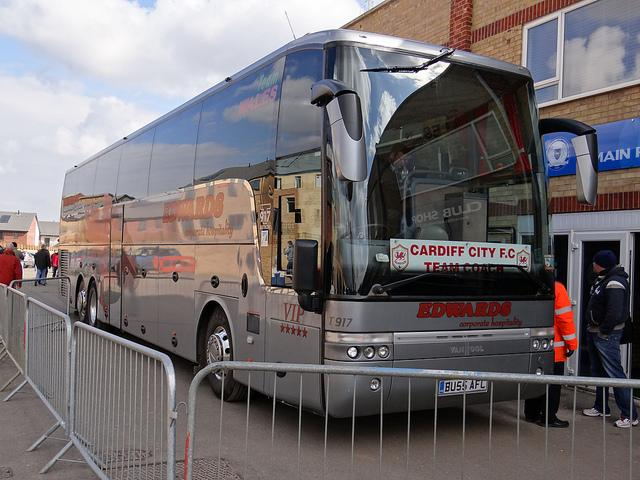Why is the man wearing an orange vest?

Choices:
A) costume
B) fashion
C) camo
D) visibility visibility 